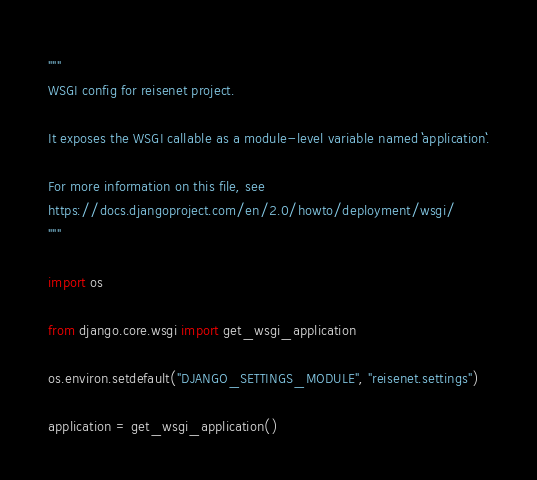<code> <loc_0><loc_0><loc_500><loc_500><_Python_>"""
WSGI config for reisenet project.

It exposes the WSGI callable as a module-level variable named ``application``.

For more information on this file, see
https://docs.djangoproject.com/en/2.0/howto/deployment/wsgi/
"""

import os

from django.core.wsgi import get_wsgi_application

os.environ.setdefault("DJANGO_SETTINGS_MODULE", "reisenet.settings")

application = get_wsgi_application()
</code> 